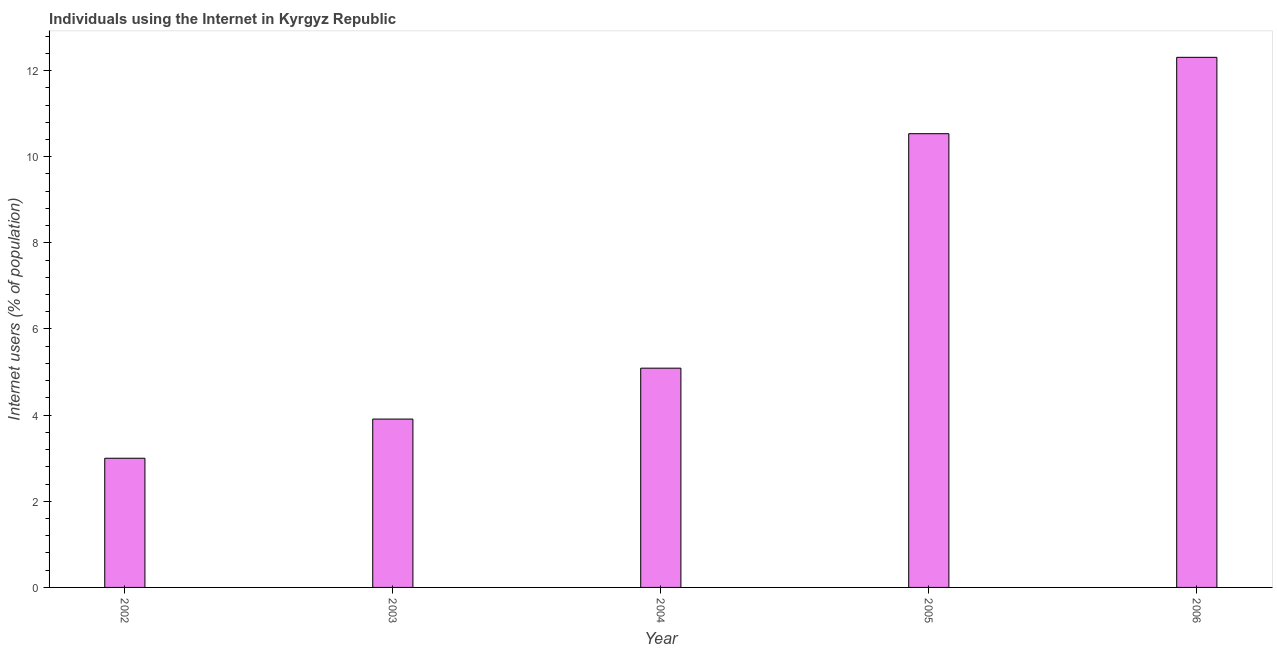Does the graph contain any zero values?
Keep it short and to the point. No. Does the graph contain grids?
Make the answer very short. No. What is the title of the graph?
Make the answer very short. Individuals using the Internet in Kyrgyz Republic. What is the label or title of the X-axis?
Keep it short and to the point. Year. What is the label or title of the Y-axis?
Keep it short and to the point. Internet users (% of population). What is the number of internet users in 2005?
Offer a very short reply. 10.53. Across all years, what is the maximum number of internet users?
Provide a short and direct response. 12.31. Across all years, what is the minimum number of internet users?
Keep it short and to the point. 3. What is the sum of the number of internet users?
Your response must be concise. 34.84. What is the difference between the number of internet users in 2002 and 2004?
Offer a very short reply. -2.09. What is the average number of internet users per year?
Your answer should be very brief. 6.97. What is the median number of internet users?
Offer a very short reply. 5.09. In how many years, is the number of internet users greater than 9.6 %?
Provide a short and direct response. 2. Do a majority of the years between 2002 and 2003 (inclusive) have number of internet users greater than 9.6 %?
Provide a succinct answer. No. What is the ratio of the number of internet users in 2002 to that in 2004?
Provide a short and direct response. 0.59. What is the difference between the highest and the second highest number of internet users?
Your answer should be compact. 1.77. Is the sum of the number of internet users in 2002 and 2006 greater than the maximum number of internet users across all years?
Your answer should be very brief. Yes. What is the difference between the highest and the lowest number of internet users?
Make the answer very short. 9.31. In how many years, is the number of internet users greater than the average number of internet users taken over all years?
Provide a succinct answer. 2. How many bars are there?
Keep it short and to the point. 5. Are the values on the major ticks of Y-axis written in scientific E-notation?
Offer a terse response. No. What is the Internet users (% of population) in 2002?
Keep it short and to the point. 3. What is the Internet users (% of population) in 2003?
Your response must be concise. 3.91. What is the Internet users (% of population) of 2004?
Your response must be concise. 5.09. What is the Internet users (% of population) of 2005?
Your answer should be very brief. 10.53. What is the Internet users (% of population) in 2006?
Your answer should be very brief. 12.31. What is the difference between the Internet users (% of population) in 2002 and 2003?
Give a very brief answer. -0.91. What is the difference between the Internet users (% of population) in 2002 and 2004?
Make the answer very short. -2.09. What is the difference between the Internet users (% of population) in 2002 and 2005?
Make the answer very short. -7.53. What is the difference between the Internet users (% of population) in 2002 and 2006?
Make the answer very short. -9.31. What is the difference between the Internet users (% of population) in 2003 and 2004?
Your answer should be very brief. -1.18. What is the difference between the Internet users (% of population) in 2003 and 2005?
Make the answer very short. -6.63. What is the difference between the Internet users (% of population) in 2003 and 2006?
Keep it short and to the point. -8.4. What is the difference between the Internet users (% of population) in 2004 and 2005?
Offer a very short reply. -5.44. What is the difference between the Internet users (% of population) in 2004 and 2006?
Your answer should be very brief. -7.22. What is the difference between the Internet users (% of population) in 2005 and 2006?
Your answer should be very brief. -1.77. What is the ratio of the Internet users (% of population) in 2002 to that in 2003?
Ensure brevity in your answer.  0.77. What is the ratio of the Internet users (% of population) in 2002 to that in 2004?
Your answer should be compact. 0.59. What is the ratio of the Internet users (% of population) in 2002 to that in 2005?
Make the answer very short. 0.28. What is the ratio of the Internet users (% of population) in 2002 to that in 2006?
Your answer should be very brief. 0.24. What is the ratio of the Internet users (% of population) in 2003 to that in 2004?
Provide a short and direct response. 0.77. What is the ratio of the Internet users (% of population) in 2003 to that in 2005?
Keep it short and to the point. 0.37. What is the ratio of the Internet users (% of population) in 2003 to that in 2006?
Ensure brevity in your answer.  0.32. What is the ratio of the Internet users (% of population) in 2004 to that in 2005?
Give a very brief answer. 0.48. What is the ratio of the Internet users (% of population) in 2004 to that in 2006?
Your answer should be compact. 0.41. What is the ratio of the Internet users (% of population) in 2005 to that in 2006?
Make the answer very short. 0.86. 